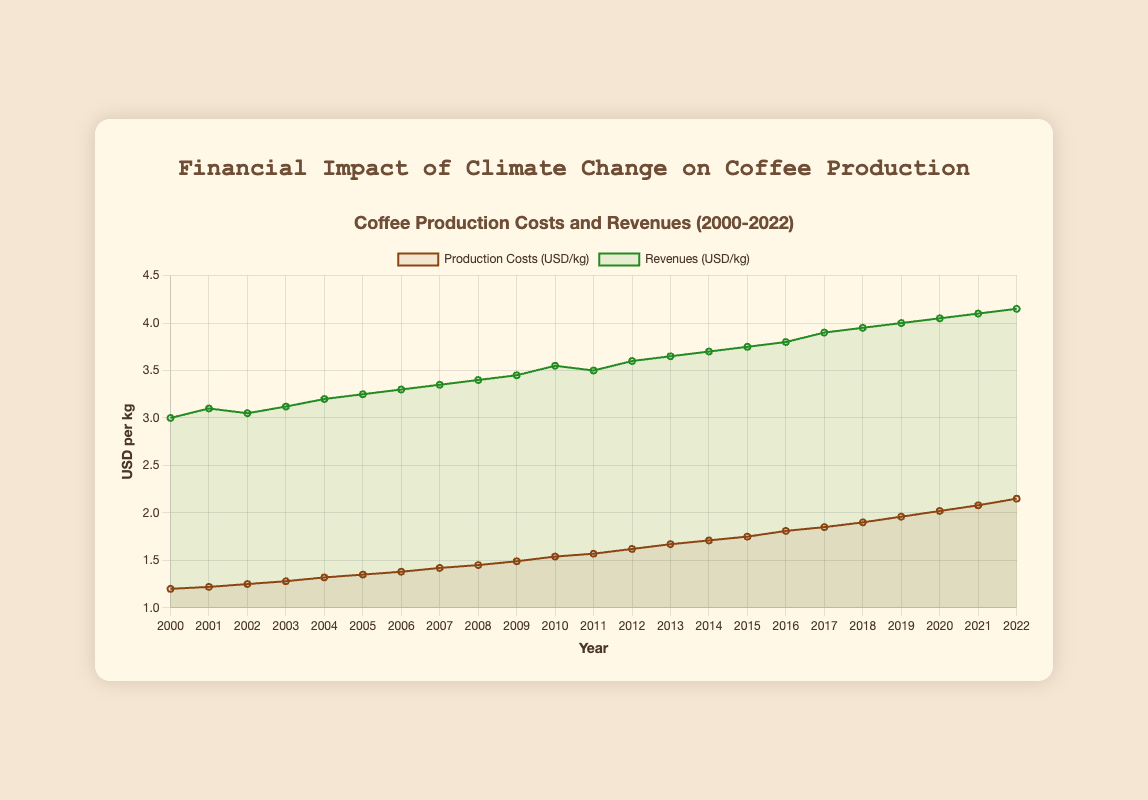What is the trend of production costs from 2000 to 2022? The trend of production costs shows a steady increase over the years. Starting from about $1.20 per kg in 2000, it gradually rises to approximately $2.15 per kg in 2022.
Answer: Steady increase How much did the revenues increase from 2000 to 2022? Revenues in 2000 were approximately $3.00 per kg and increased to about $4.15 per kg in 2022. The difference is $4.15 - $3.00.
Answer: $1.15 In what year did the production costs first exceed $1.50 per kg? Observing the chart, production costs exceeded $1.50 per kg for the first time in 2010.
Answer: 2010 Compare the growth rates of production costs and revenues between 2010 and 2020. From 2010 to 2020, production costs increased from about $1.54 to $2.02 per kg, an increase of $2.02 - $1.54 = $0.48. Revenues increased from about $3.55 to $4.05 per kg, an increase of $4.05 - $3.55 = $0.50. The revenues grew slightly faster than the production costs over this period.
Answer: Revenues grew faster What was the average revenue between 2005 and 2015? The revenues from 2005 to 2015 are $3.25, $3.30, $3.35, $3.40, $3.45, $3.55, $3.50, $3.60, $3.65, $3.70, $3.75. The average can be found by summing these values and dividing by the number of years, which is 11. The sum is $38.50, so the average is $38.50 / 11.
Answer: $3.50 Between 2010 and 2015, which year had the highest production costs? Checking the data points from 2010 to 2015, production costs in those years were $1.54, $1.57, $1.62, $1.67, $1.71, and $1.75 respectively. The highest value is in 2015.
Answer: 2015 What is the median production cost from 2000 to 2022? To find the median, we list the production costs in ascending order and find the middle value. Given there are 23 data points, the median is the 12th value, which is $1.57.
Answer: $1.57 How does the revenue in 2007 compare to the production costs in 2007? In 2007, the revenue was approximately $3.35 per kg, and the production costs were about $1.42 per kg. The revenue is much higher than the production costs.
Answer: Revenue is much higher What is the difference between revenues and production costs in 2022? In 2022, the revenue is approximately $4.15 per kg, and the production costs are about $2.15 per kg. The difference is $4.15 - $2.15.
Answer: $2.00 